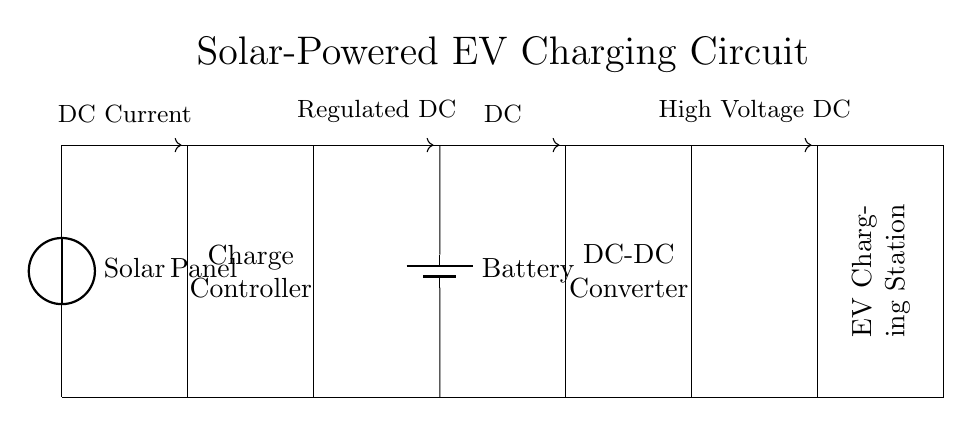What is the first component in this circuit? The first component from the left is the solar panel, as shown at the beginning of the circuit diagram.
Answer: Solar Panel What is the role of the charge controller? The charge controller regulates the voltage and current coming from the solar panel to ensure that the battery is charged properly without overcharging.
Answer: Regulates charging What type of circuit is this? This is a renewable energy circuit specifically designed for charging electric vehicles using solar power.
Answer: Renewable energy circuit What voltage does the battery supply? The battery provides direct current to the rest of the circuit, but the exact voltage is not labeled in the diagram; it's typically 12V or similar in these systems.
Answer: Not specified How does the current flow from the solar panel? The current flows in a direction from the solar panel to the charge controller, evidenced by the arrows indicating current flow.
Answer: Current flows forward What is the function of the DC-DC converter? The DC-DC converter adjusts the voltage level from the battery to meet the requirements of the electric vehicle charging station.
Answer: Voltage adjustment 